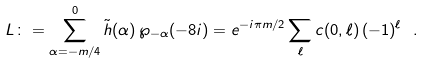Convert formula to latex. <formula><loc_0><loc_0><loc_500><loc_500>L \colon = \sum _ { \alpha = - m / 4 } ^ { 0 } \tilde { h } ( \alpha ) \, \wp _ { - \alpha } ( - 8 i ) = e ^ { - i \pi m / 2 } \sum _ { \ell } c ( 0 , \ell ) \, ( - 1 ) ^ { \ell } \ .</formula> 